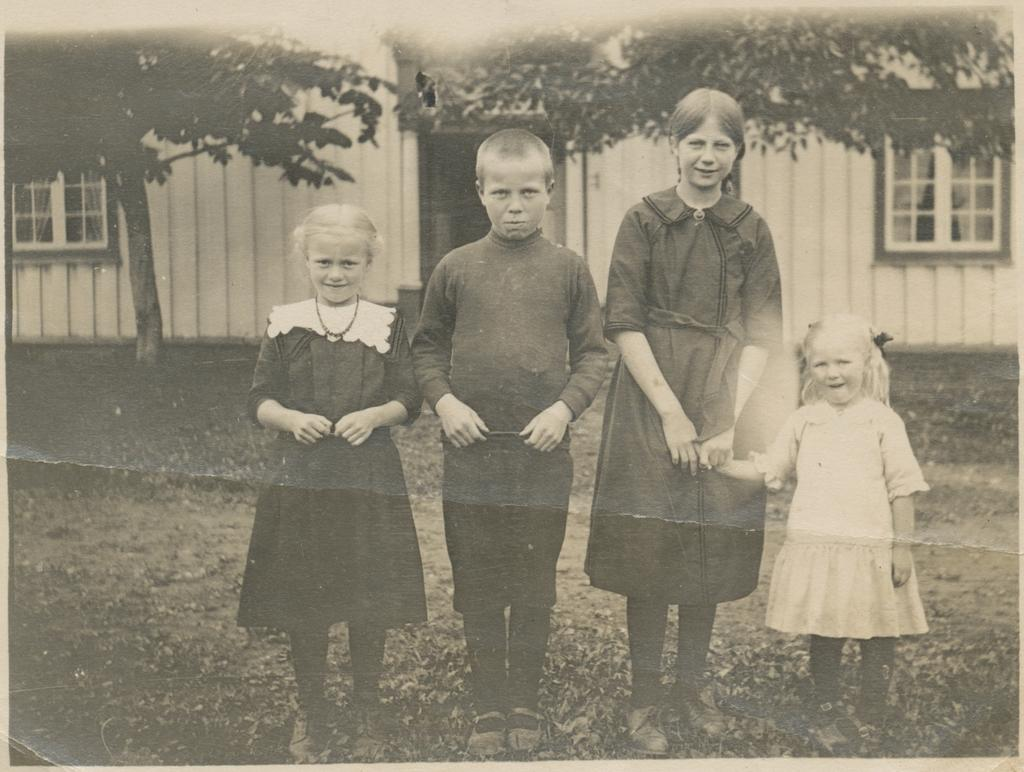How many people are present in the image? There are four people standing in the image. What can be seen in the background of the image? There is a building and trees in the background of the image. What type of vegetation is visible at the bottom of the image? There is grass visible at the bottom of the image. What type of farmer is depicted in the image? There is no farmer present in the image. What emotion is the hope expressing in the image? There is no person or emotion named "hope" depicted in the image. 